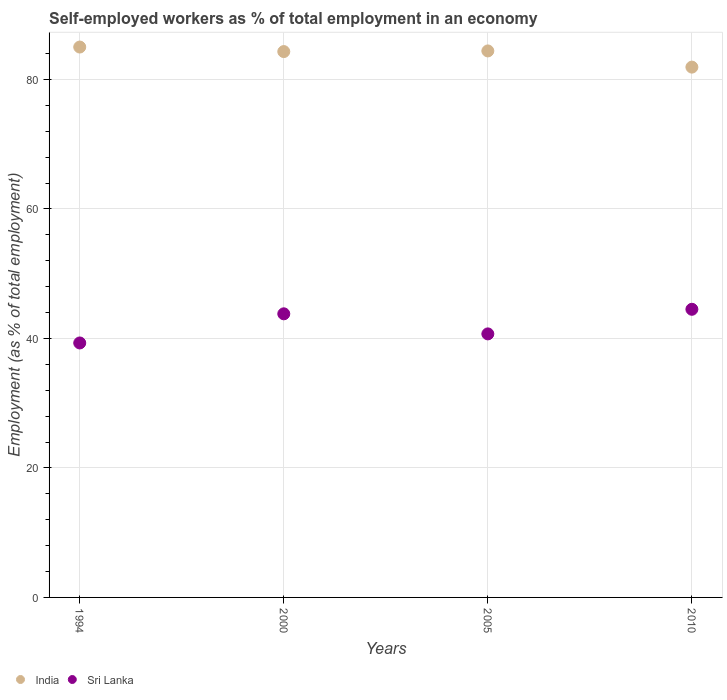What is the percentage of self-employed workers in Sri Lanka in 2010?
Provide a short and direct response. 44.5. Across all years, what is the minimum percentage of self-employed workers in India?
Your response must be concise. 81.9. In which year was the percentage of self-employed workers in Sri Lanka maximum?
Give a very brief answer. 2010. What is the total percentage of self-employed workers in India in the graph?
Your answer should be very brief. 335.6. What is the difference between the percentage of self-employed workers in India in 2000 and that in 2005?
Give a very brief answer. -0.1. What is the difference between the percentage of self-employed workers in Sri Lanka in 1994 and the percentage of self-employed workers in India in 2005?
Your answer should be compact. -45.1. What is the average percentage of self-employed workers in Sri Lanka per year?
Provide a short and direct response. 42.07. In the year 2000, what is the difference between the percentage of self-employed workers in Sri Lanka and percentage of self-employed workers in India?
Provide a short and direct response. -40.5. What is the ratio of the percentage of self-employed workers in Sri Lanka in 1994 to that in 2005?
Your response must be concise. 0.97. Is the difference between the percentage of self-employed workers in Sri Lanka in 2005 and 2010 greater than the difference between the percentage of self-employed workers in India in 2005 and 2010?
Give a very brief answer. No. What is the difference between the highest and the second highest percentage of self-employed workers in Sri Lanka?
Provide a succinct answer. 0.7. What is the difference between the highest and the lowest percentage of self-employed workers in India?
Make the answer very short. 3.1. Does the percentage of self-employed workers in Sri Lanka monotonically increase over the years?
Offer a terse response. No. Is the percentage of self-employed workers in Sri Lanka strictly greater than the percentage of self-employed workers in India over the years?
Provide a short and direct response. No. How many dotlines are there?
Provide a short and direct response. 2. What is the title of the graph?
Offer a terse response. Self-employed workers as % of total employment in an economy. What is the label or title of the X-axis?
Your response must be concise. Years. What is the label or title of the Y-axis?
Your response must be concise. Employment (as % of total employment). What is the Employment (as % of total employment) in Sri Lanka in 1994?
Make the answer very short. 39.3. What is the Employment (as % of total employment) of India in 2000?
Provide a short and direct response. 84.3. What is the Employment (as % of total employment) in Sri Lanka in 2000?
Keep it short and to the point. 43.8. What is the Employment (as % of total employment) in India in 2005?
Make the answer very short. 84.4. What is the Employment (as % of total employment) of Sri Lanka in 2005?
Provide a succinct answer. 40.7. What is the Employment (as % of total employment) in India in 2010?
Give a very brief answer. 81.9. What is the Employment (as % of total employment) of Sri Lanka in 2010?
Your answer should be compact. 44.5. Across all years, what is the maximum Employment (as % of total employment) of India?
Offer a very short reply. 85. Across all years, what is the maximum Employment (as % of total employment) of Sri Lanka?
Offer a very short reply. 44.5. Across all years, what is the minimum Employment (as % of total employment) in India?
Your answer should be very brief. 81.9. Across all years, what is the minimum Employment (as % of total employment) of Sri Lanka?
Your answer should be very brief. 39.3. What is the total Employment (as % of total employment) in India in the graph?
Make the answer very short. 335.6. What is the total Employment (as % of total employment) of Sri Lanka in the graph?
Offer a very short reply. 168.3. What is the difference between the Employment (as % of total employment) of India in 1994 and that in 2000?
Your response must be concise. 0.7. What is the difference between the Employment (as % of total employment) of India in 1994 and that in 2005?
Keep it short and to the point. 0.6. What is the difference between the Employment (as % of total employment) of Sri Lanka in 1994 and that in 2005?
Offer a terse response. -1.4. What is the difference between the Employment (as % of total employment) in Sri Lanka in 1994 and that in 2010?
Give a very brief answer. -5.2. What is the difference between the Employment (as % of total employment) in Sri Lanka in 2000 and that in 2010?
Provide a succinct answer. -0.7. What is the difference between the Employment (as % of total employment) of India in 2005 and that in 2010?
Your answer should be compact. 2.5. What is the difference between the Employment (as % of total employment) of India in 1994 and the Employment (as % of total employment) of Sri Lanka in 2000?
Give a very brief answer. 41.2. What is the difference between the Employment (as % of total employment) in India in 1994 and the Employment (as % of total employment) in Sri Lanka in 2005?
Make the answer very short. 44.3. What is the difference between the Employment (as % of total employment) of India in 1994 and the Employment (as % of total employment) of Sri Lanka in 2010?
Your answer should be compact. 40.5. What is the difference between the Employment (as % of total employment) of India in 2000 and the Employment (as % of total employment) of Sri Lanka in 2005?
Offer a terse response. 43.6. What is the difference between the Employment (as % of total employment) of India in 2000 and the Employment (as % of total employment) of Sri Lanka in 2010?
Make the answer very short. 39.8. What is the difference between the Employment (as % of total employment) in India in 2005 and the Employment (as % of total employment) in Sri Lanka in 2010?
Your response must be concise. 39.9. What is the average Employment (as % of total employment) of India per year?
Your response must be concise. 83.9. What is the average Employment (as % of total employment) in Sri Lanka per year?
Your answer should be very brief. 42.08. In the year 1994, what is the difference between the Employment (as % of total employment) of India and Employment (as % of total employment) of Sri Lanka?
Provide a succinct answer. 45.7. In the year 2000, what is the difference between the Employment (as % of total employment) in India and Employment (as % of total employment) in Sri Lanka?
Provide a succinct answer. 40.5. In the year 2005, what is the difference between the Employment (as % of total employment) of India and Employment (as % of total employment) of Sri Lanka?
Your answer should be compact. 43.7. In the year 2010, what is the difference between the Employment (as % of total employment) of India and Employment (as % of total employment) of Sri Lanka?
Offer a very short reply. 37.4. What is the ratio of the Employment (as % of total employment) in India in 1994 to that in 2000?
Give a very brief answer. 1.01. What is the ratio of the Employment (as % of total employment) of Sri Lanka in 1994 to that in 2000?
Offer a very short reply. 0.9. What is the ratio of the Employment (as % of total employment) in India in 1994 to that in 2005?
Keep it short and to the point. 1.01. What is the ratio of the Employment (as % of total employment) in Sri Lanka in 1994 to that in 2005?
Offer a very short reply. 0.97. What is the ratio of the Employment (as % of total employment) of India in 1994 to that in 2010?
Keep it short and to the point. 1.04. What is the ratio of the Employment (as % of total employment) in Sri Lanka in 1994 to that in 2010?
Offer a terse response. 0.88. What is the ratio of the Employment (as % of total employment) in Sri Lanka in 2000 to that in 2005?
Offer a terse response. 1.08. What is the ratio of the Employment (as % of total employment) of India in 2000 to that in 2010?
Your answer should be compact. 1.03. What is the ratio of the Employment (as % of total employment) of Sri Lanka in 2000 to that in 2010?
Provide a succinct answer. 0.98. What is the ratio of the Employment (as % of total employment) in India in 2005 to that in 2010?
Your answer should be compact. 1.03. What is the ratio of the Employment (as % of total employment) of Sri Lanka in 2005 to that in 2010?
Offer a terse response. 0.91. What is the difference between the highest and the second highest Employment (as % of total employment) of India?
Ensure brevity in your answer.  0.6. What is the difference between the highest and the lowest Employment (as % of total employment) in India?
Provide a short and direct response. 3.1. 